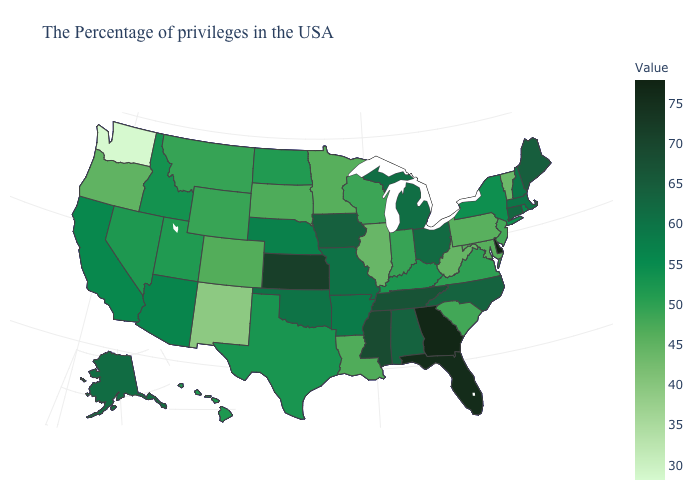Does Kansas have the highest value in the MidWest?
Give a very brief answer. Yes. Which states have the highest value in the USA?
Quick response, please. Delaware. 